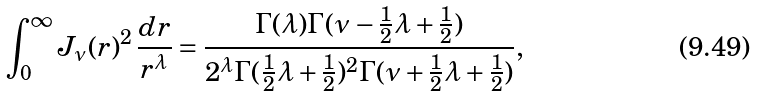Convert formula to latex. <formula><loc_0><loc_0><loc_500><loc_500>\int _ { 0 } ^ { \infty } J _ { \nu } ( r ) ^ { 2 } \, \frac { d r } { r ^ { \lambda } } = \frac { \Gamma ( \lambda ) \Gamma ( \nu - \frac { 1 } { 2 } \lambda + \frac { 1 } { 2 } ) } { 2 ^ { \lambda } \Gamma ( \frac { 1 } { 2 } \lambda + \frac { 1 } { 2 } ) ^ { 2 } \Gamma ( \nu + \frac { 1 } { 2 } \lambda + \frac { 1 } { 2 } ) } ,</formula> 